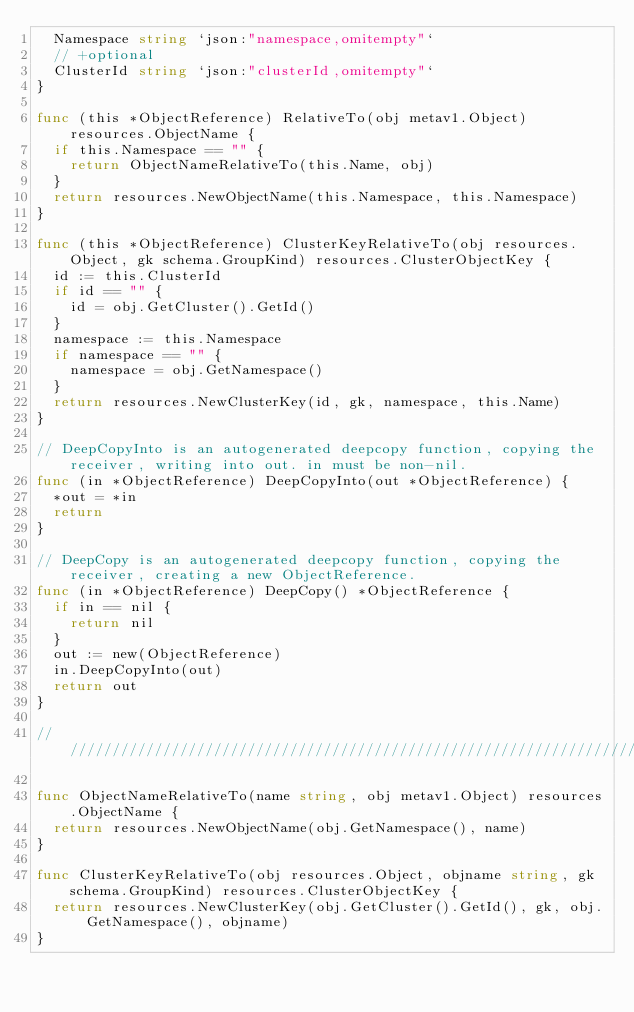Convert code to text. <code><loc_0><loc_0><loc_500><loc_500><_Go_>	Namespace string `json:"namespace,omitempty"`
	// +optional
	ClusterId string `json:"clusterId,omitempty"`
}

func (this *ObjectReference) RelativeTo(obj metav1.Object) resources.ObjectName {
	if this.Namespace == "" {
		return ObjectNameRelativeTo(this.Name, obj)
	}
	return resources.NewObjectName(this.Namespace, this.Namespace)
}

func (this *ObjectReference) ClusterKeyRelativeTo(obj resources.Object, gk schema.GroupKind) resources.ClusterObjectKey {
	id := this.ClusterId
	if id == "" {
		id = obj.GetCluster().GetId()
	}
	namespace := this.Namespace
	if namespace == "" {
		namespace = obj.GetNamespace()
	}
	return resources.NewClusterKey(id, gk, namespace, this.Name)
}

// DeepCopyInto is an autogenerated deepcopy function, copying the receiver, writing into out. in must be non-nil.
func (in *ObjectReference) DeepCopyInto(out *ObjectReference) {
	*out = *in
	return
}

// DeepCopy is an autogenerated deepcopy function, copying the receiver, creating a new ObjectReference.
func (in *ObjectReference) DeepCopy() *ObjectReference {
	if in == nil {
		return nil
	}
	out := new(ObjectReference)
	in.DeepCopyInto(out)
	return out
}

////////////////////////////////////////////////////////////////////////////////

func ObjectNameRelativeTo(name string, obj metav1.Object) resources.ObjectName {
	return resources.NewObjectName(obj.GetNamespace(), name)
}

func ClusterKeyRelativeTo(obj resources.Object, objname string, gk schema.GroupKind) resources.ClusterObjectKey {
	return resources.NewClusterKey(obj.GetCluster().GetId(), gk, obj.GetNamespace(), objname)
}
</code> 